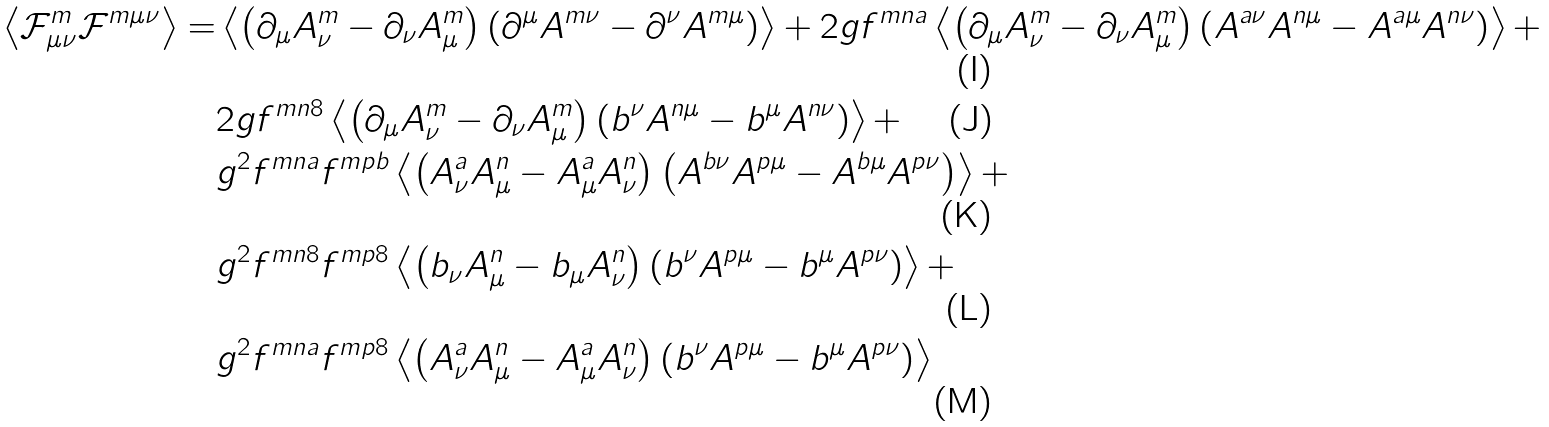Convert formula to latex. <formula><loc_0><loc_0><loc_500><loc_500>\left \langle \mathcal { F } ^ { m } _ { \mu \nu } \mathcal { F } ^ { m \mu \nu } \right \rangle = & \left \langle \left ( \partial _ { \mu } A ^ { m } _ { \nu } - \partial _ { \nu } A ^ { m } _ { \mu } \right ) \left ( \partial ^ { \mu } A ^ { m \nu } - \partial ^ { \nu } A ^ { m \mu } \right ) \right \rangle + 2 g f ^ { m n a } \left \langle \left ( \partial _ { \mu } A ^ { m } _ { \nu } - \partial _ { \nu } A ^ { m } _ { \mu } \right ) \left ( A ^ { a \nu } A ^ { n \mu } - A ^ { a \mu } A ^ { n \nu } \right ) \right \rangle + \\ & 2 g f ^ { m n 8 } \left \langle \left ( \partial _ { \mu } A ^ { m } _ { \nu } - \partial _ { \nu } A ^ { m } _ { \mu } \right ) \left ( b ^ { \nu } A ^ { n \mu } - b ^ { \mu } A ^ { n \nu } \right ) \right \rangle + \\ & g ^ { 2 } f ^ { m n a } f ^ { m p b } \left \langle \left ( A ^ { a } _ { \nu } A ^ { n } _ { \mu } - A ^ { a } _ { \mu } A ^ { n } _ { \nu } \right ) \left ( A ^ { b \nu } A ^ { p \mu } - A ^ { b \mu } A ^ { p \nu } \right ) \right \rangle + \\ & g ^ { 2 } f ^ { m n 8 } f ^ { m p 8 } \left \langle \left ( b _ { \nu } A ^ { n } _ { \mu } - b _ { \mu } A ^ { n } _ { \nu } \right ) \left ( b ^ { \nu } A ^ { p \mu } - b ^ { \mu } A ^ { p \nu } \right ) \right \rangle + \\ & g ^ { 2 } f ^ { m n a } f ^ { m p 8 } \left \langle \left ( A ^ { a } _ { \nu } A ^ { n } _ { \mu } - A ^ { a } _ { \mu } A ^ { n } _ { \nu } \right ) \left ( b ^ { \nu } A ^ { p \mu } - b ^ { \mu } A ^ { p \nu } \right ) \right \rangle</formula> 